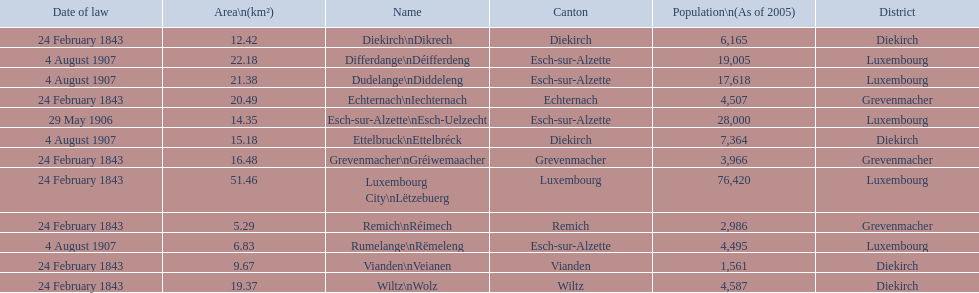How many luxembourg cities had a date of law of feb 24, 1843? 7. 